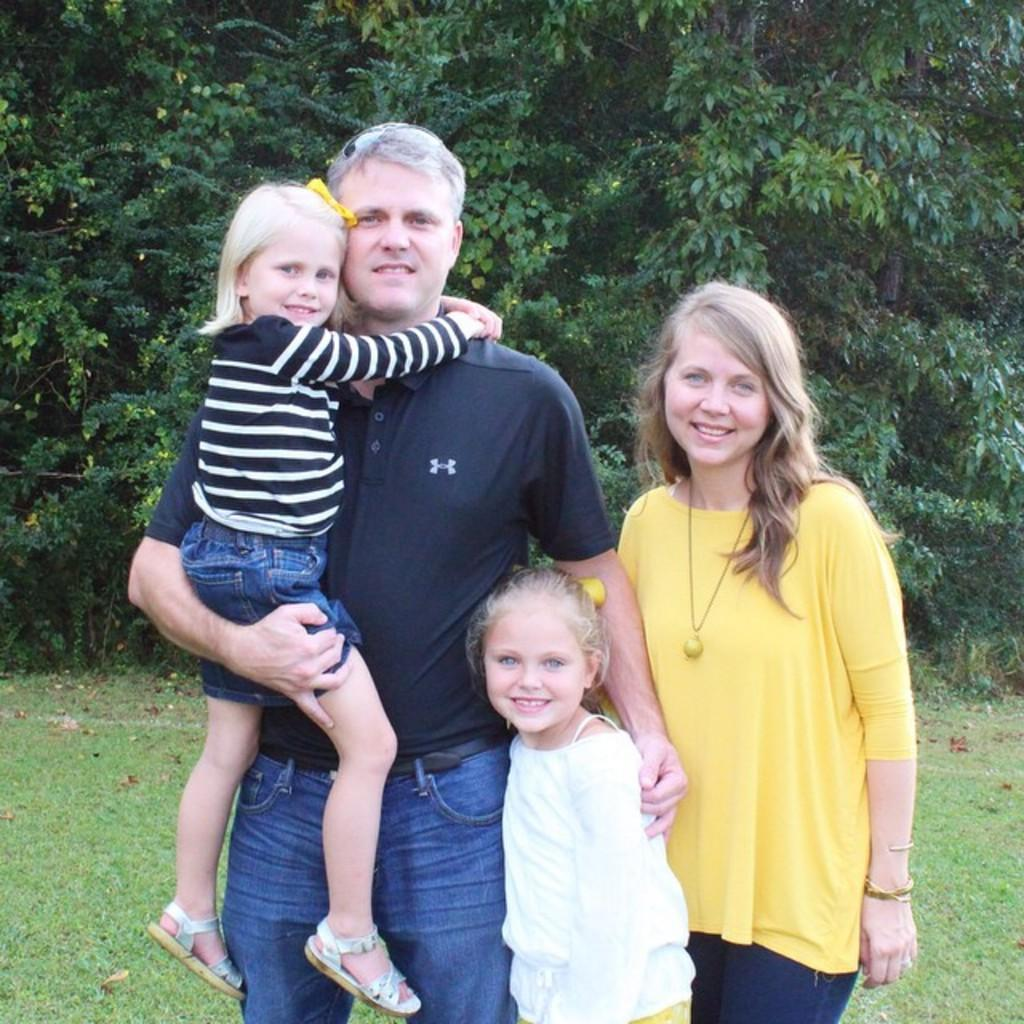What is happening in the image? There are people standing in the image. What can be seen in the background of the image? There are trees visible behind the people in the image. What type of cave is visible behind the people in the image? There is no cave visible in the image; it features people standing in front of trees. What color is the skirt worn by the person on the left in the image? There is no person wearing a skirt in the image, as the provided facts only mention people standing. 